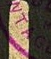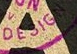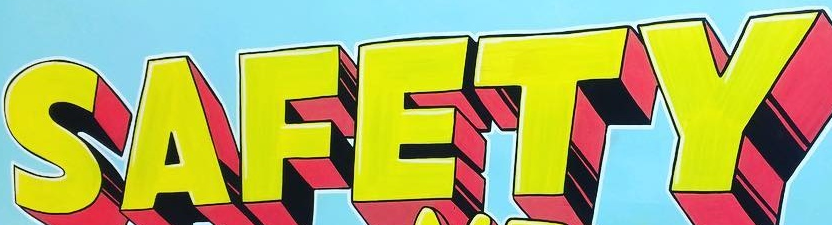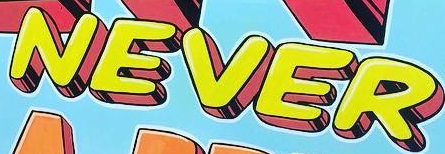What words can you see in these images in sequence, separated by a semicolon? NTAG; DESIGN; SAFETY; NEVER 